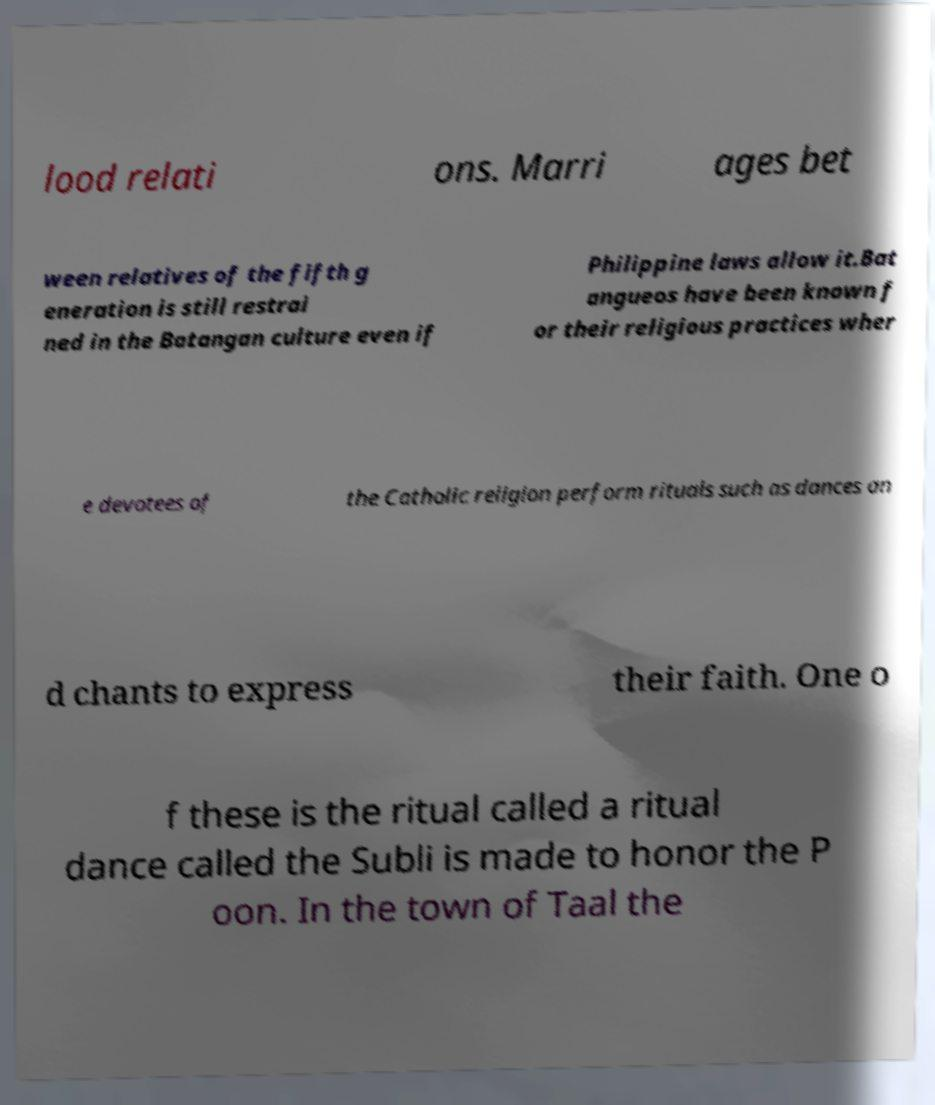Please read and relay the text visible in this image. What does it say? lood relati ons. Marri ages bet ween relatives of the fifth g eneration is still restrai ned in the Batangan culture even if Philippine laws allow it.Bat angueos have been known f or their religious practices wher e devotees of the Catholic religion perform rituals such as dances an d chants to express their faith. One o f these is the ritual called a ritual dance called the Subli is made to honor the P oon. In the town of Taal the 